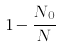Convert formula to latex. <formula><loc_0><loc_0><loc_500><loc_500>1 - \frac { N _ { 0 } } { N }</formula> 